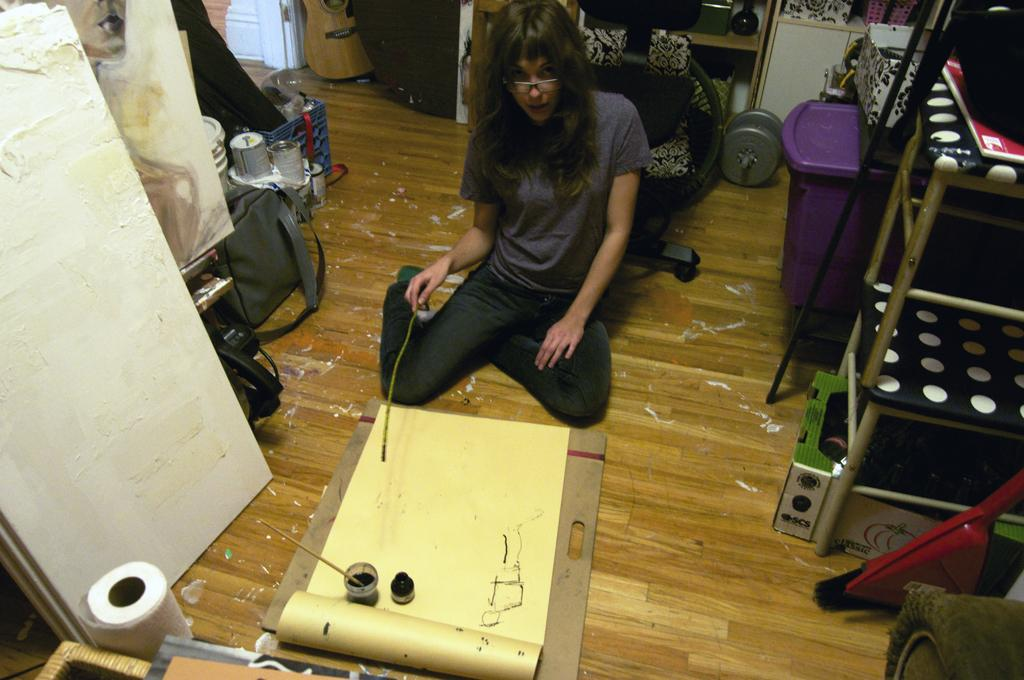What is the person in the image doing? The person is sitting on the floor in the image. What is the person holding in the image? The person is holding a stick. What else can be seen around the person in the image? There are a few objects around the person. What type of leaf is the person reading in the image? There is no leaf present in the image, and the person is not reading anything. 